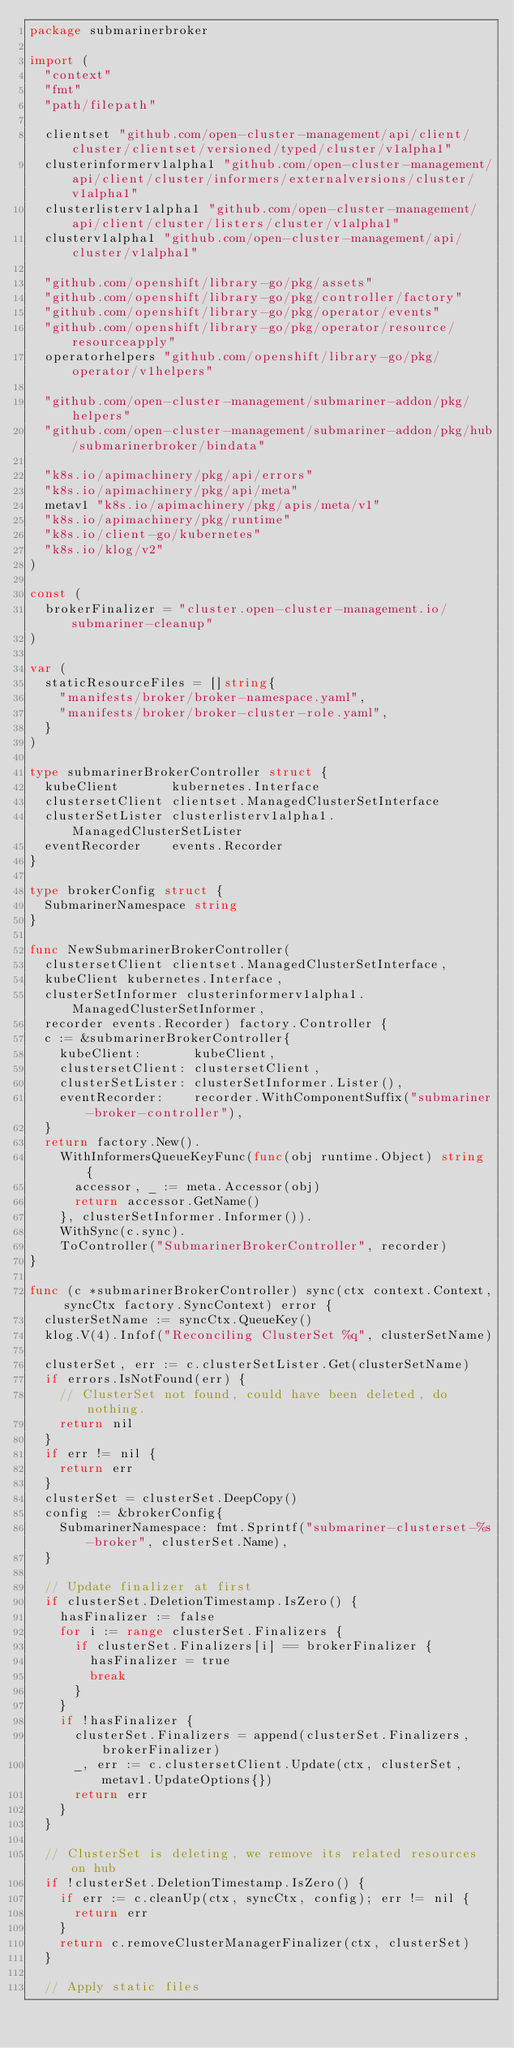<code> <loc_0><loc_0><loc_500><loc_500><_Go_>package submarinerbroker

import (
	"context"
	"fmt"
	"path/filepath"

	clientset "github.com/open-cluster-management/api/client/cluster/clientset/versioned/typed/cluster/v1alpha1"
	clusterinformerv1alpha1 "github.com/open-cluster-management/api/client/cluster/informers/externalversions/cluster/v1alpha1"
	clusterlisterv1alpha1 "github.com/open-cluster-management/api/client/cluster/listers/cluster/v1alpha1"
	clusterv1alpha1 "github.com/open-cluster-management/api/cluster/v1alpha1"

	"github.com/openshift/library-go/pkg/assets"
	"github.com/openshift/library-go/pkg/controller/factory"
	"github.com/openshift/library-go/pkg/operator/events"
	"github.com/openshift/library-go/pkg/operator/resource/resourceapply"
	operatorhelpers "github.com/openshift/library-go/pkg/operator/v1helpers"

	"github.com/open-cluster-management/submariner-addon/pkg/helpers"
	"github.com/open-cluster-management/submariner-addon/pkg/hub/submarinerbroker/bindata"

	"k8s.io/apimachinery/pkg/api/errors"
	"k8s.io/apimachinery/pkg/api/meta"
	metav1 "k8s.io/apimachinery/pkg/apis/meta/v1"
	"k8s.io/apimachinery/pkg/runtime"
	"k8s.io/client-go/kubernetes"
	"k8s.io/klog/v2"
)

const (
	brokerFinalizer = "cluster.open-cluster-management.io/submariner-cleanup"
)

var (
	staticResourceFiles = []string{
		"manifests/broker/broker-namespace.yaml",
		"manifests/broker/broker-cluster-role.yaml",
	}
)

type submarinerBrokerController struct {
	kubeClient       kubernetes.Interface
	clustersetClient clientset.ManagedClusterSetInterface
	clusterSetLister clusterlisterv1alpha1.ManagedClusterSetLister
	eventRecorder    events.Recorder
}

type brokerConfig struct {
	SubmarinerNamespace string
}

func NewSubmarinerBrokerController(
	clustersetClient clientset.ManagedClusterSetInterface,
	kubeClient kubernetes.Interface,
	clusterSetInformer clusterinformerv1alpha1.ManagedClusterSetInformer,
	recorder events.Recorder) factory.Controller {
	c := &submarinerBrokerController{
		kubeClient:       kubeClient,
		clustersetClient: clustersetClient,
		clusterSetLister: clusterSetInformer.Lister(),
		eventRecorder:    recorder.WithComponentSuffix("submariner-broker-controller"),
	}
	return factory.New().
		WithInformersQueueKeyFunc(func(obj runtime.Object) string {
			accessor, _ := meta.Accessor(obj)
			return accessor.GetName()
		}, clusterSetInformer.Informer()).
		WithSync(c.sync).
		ToController("SubmarinerBrokerController", recorder)
}

func (c *submarinerBrokerController) sync(ctx context.Context, syncCtx factory.SyncContext) error {
	clusterSetName := syncCtx.QueueKey()
	klog.V(4).Infof("Reconciling ClusterSet %q", clusterSetName)

	clusterSet, err := c.clusterSetLister.Get(clusterSetName)
	if errors.IsNotFound(err) {
		// ClusterSet not found, could have been deleted, do nothing.
		return nil
	}
	if err != nil {
		return err
	}
	clusterSet = clusterSet.DeepCopy()
	config := &brokerConfig{
		SubmarinerNamespace: fmt.Sprintf("submariner-clusterset-%s-broker", clusterSet.Name),
	}

	// Update finalizer at first
	if clusterSet.DeletionTimestamp.IsZero() {
		hasFinalizer := false
		for i := range clusterSet.Finalizers {
			if clusterSet.Finalizers[i] == brokerFinalizer {
				hasFinalizer = true
				break
			}
		}
		if !hasFinalizer {
			clusterSet.Finalizers = append(clusterSet.Finalizers, brokerFinalizer)
			_, err := c.clustersetClient.Update(ctx, clusterSet, metav1.UpdateOptions{})
			return err
		}
	}

	// ClusterSet is deleting, we remove its related resources on hub
	if !clusterSet.DeletionTimestamp.IsZero() {
		if err := c.cleanUp(ctx, syncCtx, config); err != nil {
			return err
		}
		return c.removeClusterManagerFinalizer(ctx, clusterSet)
	}

	// Apply static files</code> 